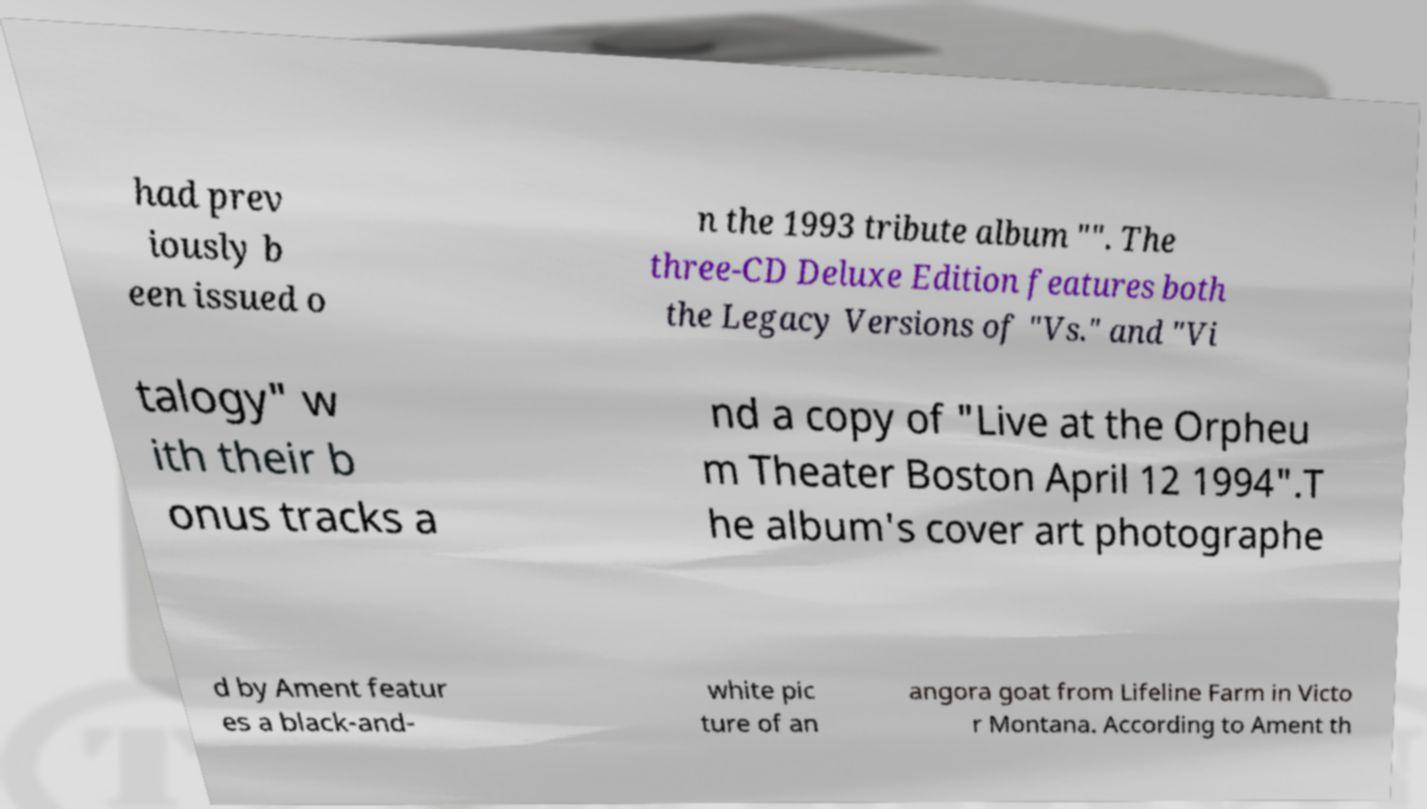Can you read and provide the text displayed in the image?This photo seems to have some interesting text. Can you extract and type it out for me? had prev iously b een issued o n the 1993 tribute album "". The three-CD Deluxe Edition features both the Legacy Versions of "Vs." and "Vi talogy" w ith their b onus tracks a nd a copy of "Live at the Orpheu m Theater Boston April 12 1994".T he album's cover art photographe d by Ament featur es a black-and- white pic ture of an angora goat from Lifeline Farm in Victo r Montana. According to Ament th 